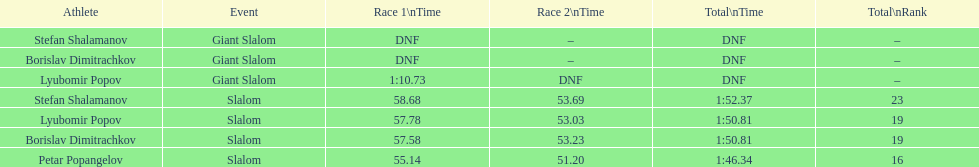How many minutes or seconds did it take lyubomir popov to conclude the giant slalom during the initial race? 1:10.73. Could you parse the entire table as a dict? {'header': ['Athlete', 'Event', 'Race 1\\nTime', 'Race 2\\nTime', 'Total\\nTime', 'Total\\nRank'], 'rows': [['Stefan Shalamanov', 'Giant Slalom', 'DNF', '–', 'DNF', '–'], ['Borislav Dimitrachkov', 'Giant Slalom', 'DNF', '–', 'DNF', '–'], ['Lyubomir Popov', 'Giant Slalom', '1:10.73', 'DNF', 'DNF', '–'], ['Stefan Shalamanov', 'Slalom', '58.68', '53.69', '1:52.37', '23'], ['Lyubomir Popov', 'Slalom', '57.78', '53.03', '1:50.81', '19'], ['Borislav Dimitrachkov', 'Slalom', '57.58', '53.23', '1:50.81', '19'], ['Petar Popangelov', 'Slalom', '55.14', '51.20', '1:46.34', '16']]} 